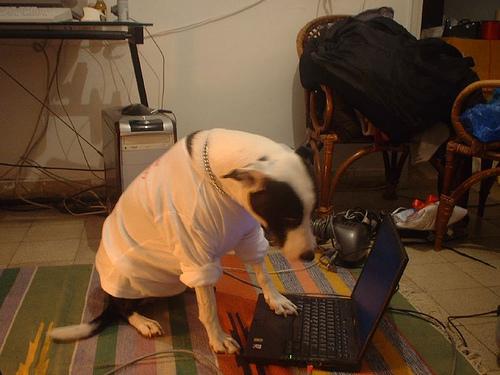Has the room been recently tidied up?
Write a very short answer. No. What is the dog playing with?
Answer briefly. Laptop. What is this animal wearing?
Quick response, please. Shirt. 